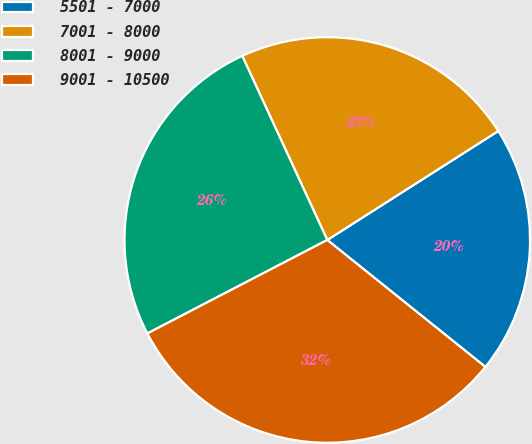Convert chart to OTSL. <chart><loc_0><loc_0><loc_500><loc_500><pie_chart><fcel>5501 - 7000<fcel>7001 - 8000<fcel>8001 - 9000<fcel>9001 - 10500<nl><fcel>19.8%<fcel>22.86%<fcel>25.74%<fcel>31.61%<nl></chart> 